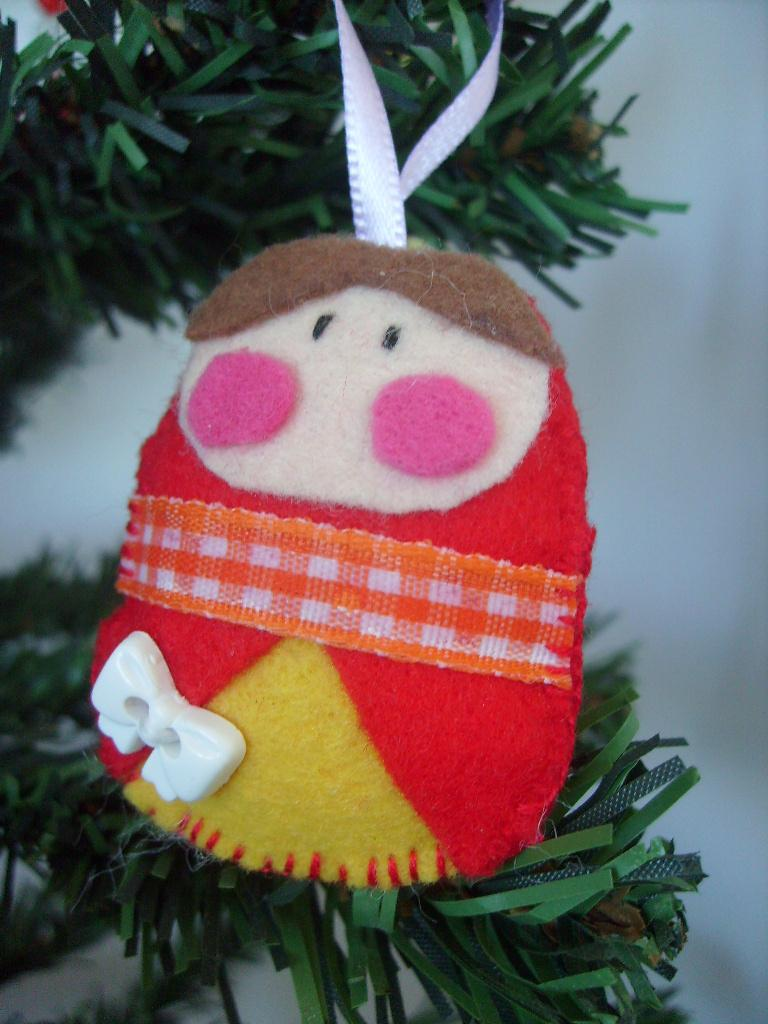What is the main subject in the foreground of the image? There is a toy in the foreground of the image. What can be seen in the background of the image? There are decorative objects in the background of the image, and the background appears to be a wall. What type of car is parked in front of the wall in the image? There is no car present in the image; it features a toy in the foreground and decorative objects in the background. What flavor of jam can be seen on the decorative objects in the image? There is no jam present in the image; the decorative objects are not related to food or jam. 